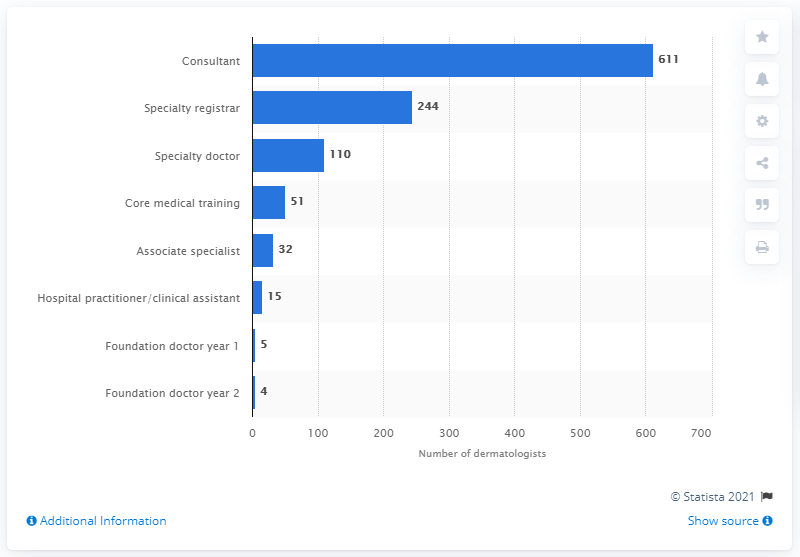List a handful of essential elements in this visual. In April 2020, there were 611 dermatology consultants registered in the UK. There were 244 dermatology specialists registered in the United Kingdom in April 2020. 